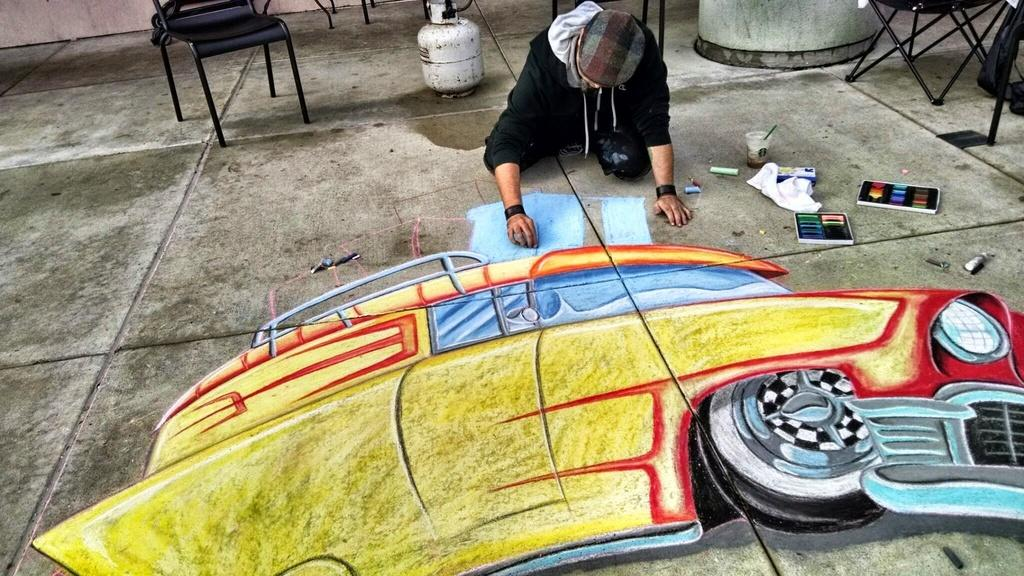What is the person in the image doing? The person is drawing a car. What tools is the person using for their drawing? The person is using painting items. Where is the drawing located in the image? The drawing is on the floor. What type of furniture is present in the image? There are chairs in the image. Can you see the parent of the person drawing the car in the image? There is no mention of a parent in the image, so we cannot determine if they are present or not. 